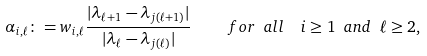<formula> <loc_0><loc_0><loc_500><loc_500>\alpha _ { i , \ell } \colon = w _ { i , \ell } \frac { | \lambda _ { \ell + 1 } - \lambda _ { j ( \ell + 1 ) } | } { | \lambda _ { \ell } - \lambda _ { j ( \ell ) } | } \quad \ f o r \ a l l \ \ i \geq 1 \ a n d \ \ell \geq 2 ,</formula> 